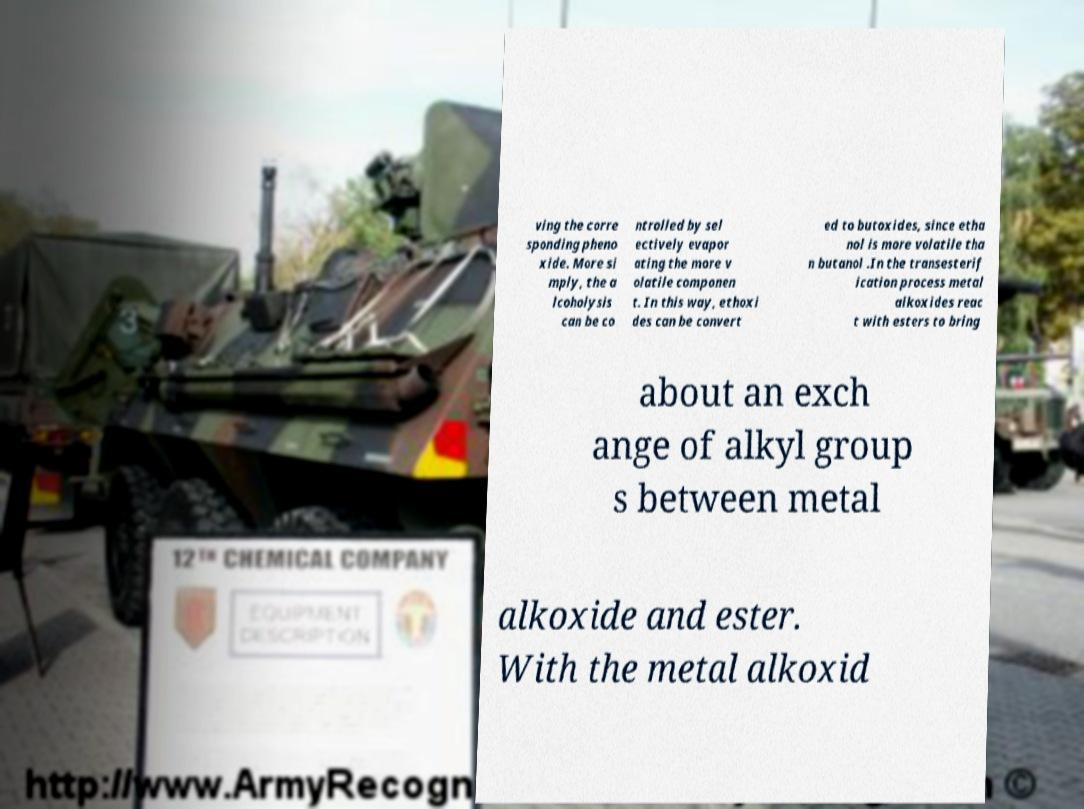What messages or text are displayed in this image? I need them in a readable, typed format. ving the corre sponding pheno xide. More si mply, the a lcoholysis can be co ntrolled by sel ectively evapor ating the more v olatile componen t. In this way, ethoxi des can be convert ed to butoxides, since etha nol is more volatile tha n butanol .In the transesterif ication process metal alkoxides reac t with esters to bring about an exch ange of alkyl group s between metal alkoxide and ester. With the metal alkoxid 